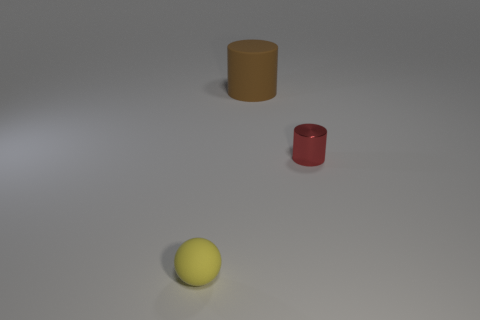Is there anything else that has the same material as the red thing?
Give a very brief answer. No. There is a brown rubber object; is its size the same as the thing right of the brown rubber cylinder?
Your answer should be very brief. No. Do the object left of the brown rubber cylinder and the cylinder that is behind the tiny metallic thing have the same material?
Offer a very short reply. Yes. There is a rubber object that is in front of the brown object; is it the same size as the big cylinder?
Provide a short and direct response. No. Do the metallic thing and the thing that is left of the large brown rubber thing have the same color?
Your answer should be very brief. No. There is a small yellow thing; what shape is it?
Offer a terse response. Sphere. Is the tiny metal cylinder the same color as the big cylinder?
Offer a very short reply. No. What number of things are either rubber things that are to the right of the small yellow rubber sphere or cyan spheres?
Your answer should be compact. 1. The yellow thing that is the same material as the brown thing is what size?
Offer a terse response. Small. Is the number of big matte things in front of the brown cylinder greater than the number of small red cylinders?
Your answer should be very brief. No. 